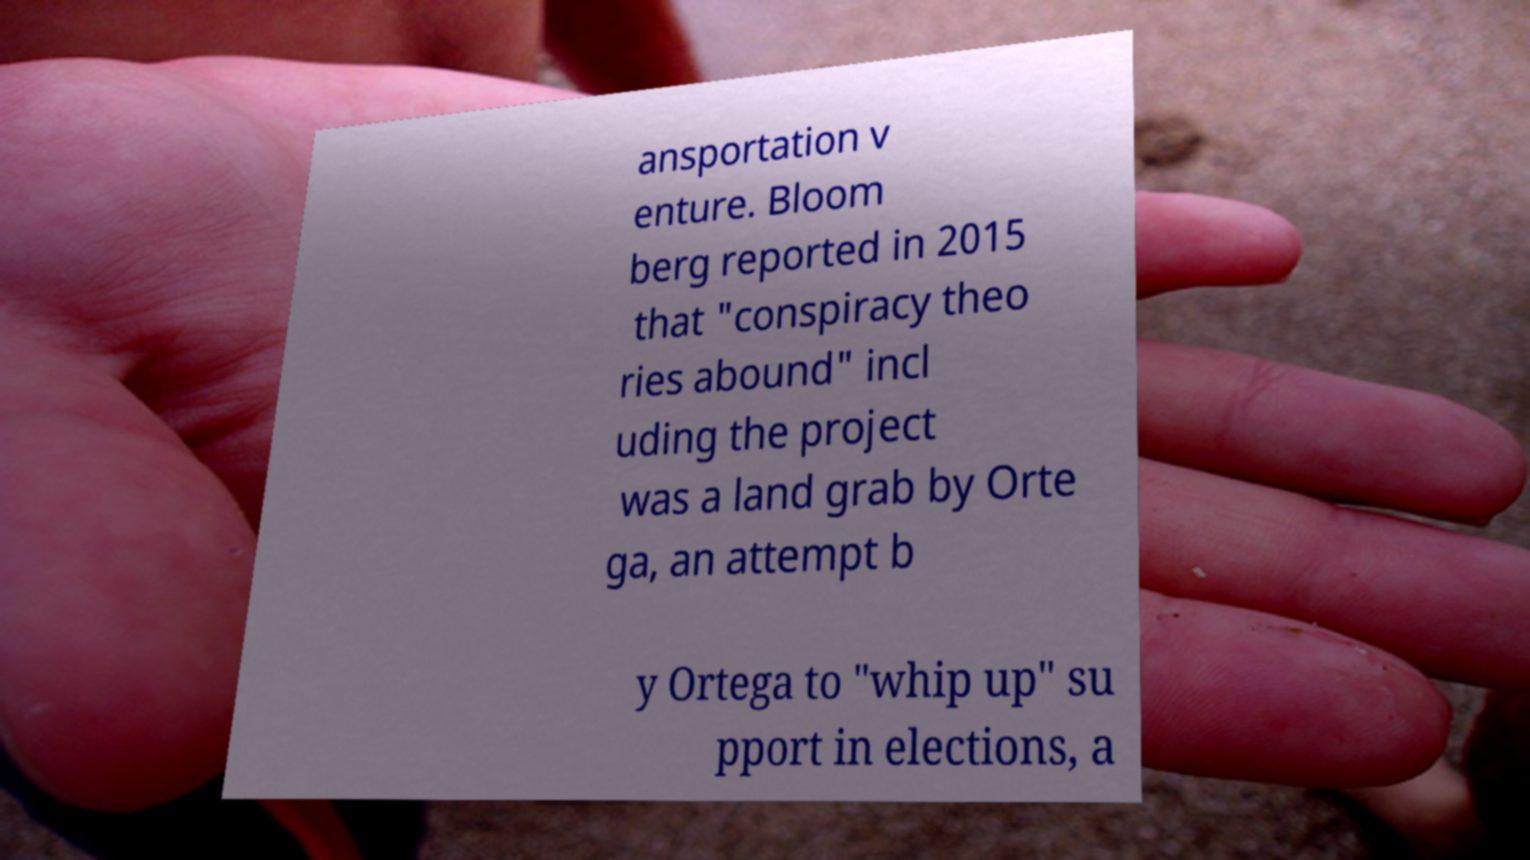For documentation purposes, I need the text within this image transcribed. Could you provide that? ansportation v enture. Bloom berg reported in 2015 that "conspiracy theo ries abound" incl uding the project was a land grab by Orte ga, an attempt b y Ortega to "whip up" su pport in elections, a 